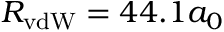Convert formula to latex. <formula><loc_0><loc_0><loc_500><loc_500>R _ { v d W } = 4 4 . 1 a _ { 0 }</formula> 